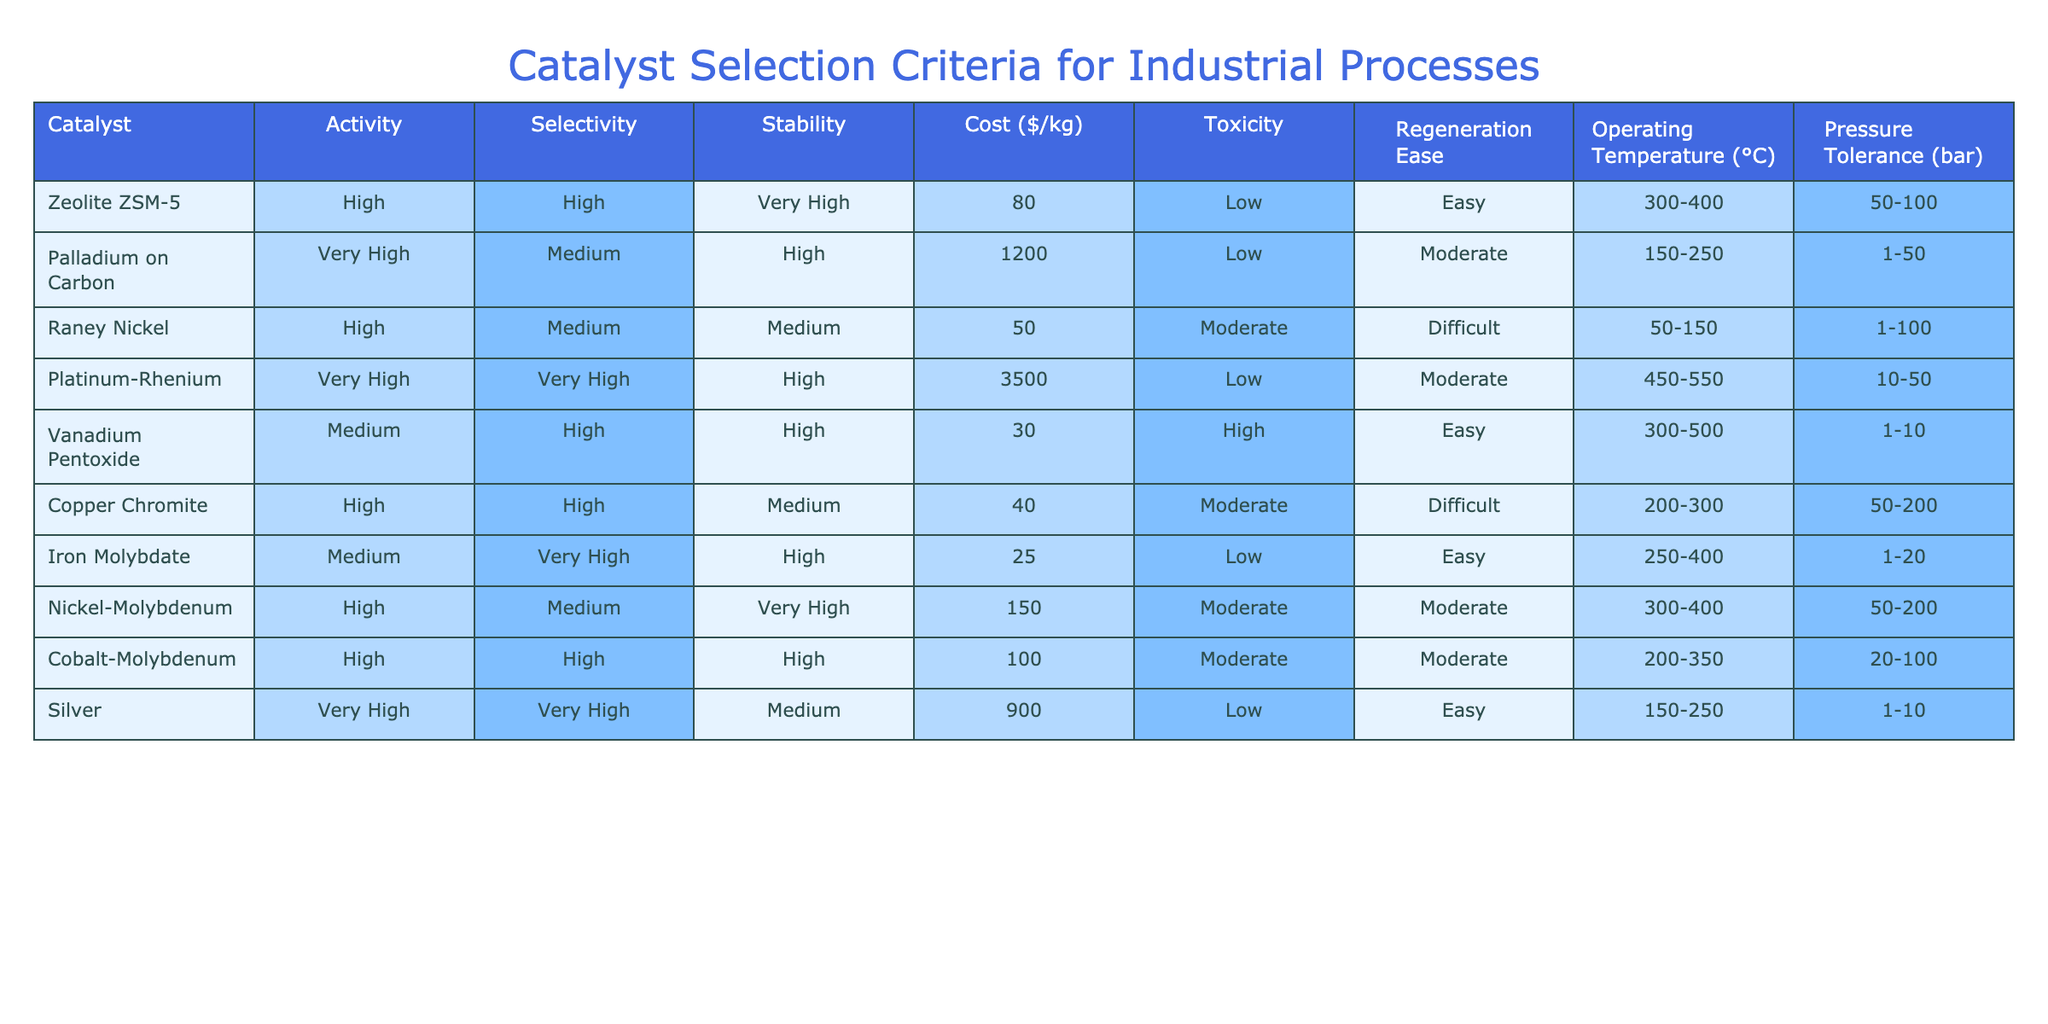What is the cost of Platinum-Rhenium? The cost value for Platinum-Rhenium is directly listed in the table. It shows as 3500 dollars per kilogram.
Answer: 3500 Which catalyst has the highest selectivity? By looking at the selectivity column, both Platinum-Rhenium and Silver have a selectivity rating of "Very High," which is the highest compared to the other catalysts listed.
Answer: Platinum-Rhenium and Silver What is the average cost of catalysts with very high activity? The catalysts with very high activity are Palladium on Carbon, Platinum-Rhenium, and Silver. Their costs are 1200, 3500, and 900 dollars respectively. The sum is 1200 + 3500 + 900 = 5600, and dividing by 3 gives 5600 / 3 = 1866.67 dollars per kilogram.
Answer: 1866.67 Is Zeolite ZSM-5 more stable than Nickel-Molybdenum? From the stability column, Zeolite ZSM-5 is rated as "Very High" while Nickel-Molybdenum is rated "Very High." Since both have the same stability rating, it can be concluded that they are equal in stability.
Answer: No Which catalyst has the lowest cost and very high stability? The only catalyst with "Very High" stability and the lowest cost is Iron Molybdate, priced at 25 dollars per kilogram, according to the table.
Answer: Iron Molybdate What is the pressure tolerance of Copper Chromite? The pressure tolerance for Copper Chromite is given in the table as 50-200 bar.
Answer: 50-200 Are all catalysts with low toxicity also easy to regenerate? From the table, both Zeolite ZSM-5 and Palladium on Carbon have low toxicity. However, Zeolite ZSM-5 is marked as easy to regenerate, while Palladium on Carbon is marked as moderate for regeneration ease. It concludes that not all catalysts with low toxicity are easy to regenerate.
Answer: No What is the range of operating temperatures for Vanadium Pentoxide? Vanadium Pentoxide's operating temperature range is specified in the table as 300-500 degrees Celsius.
Answer: 300-500 Which catalyst has both medium selectivity and easy regeneration? According to the table, Copper Chromite has medium selectivity and easy regeneration.
Answer: Copper Chromite 